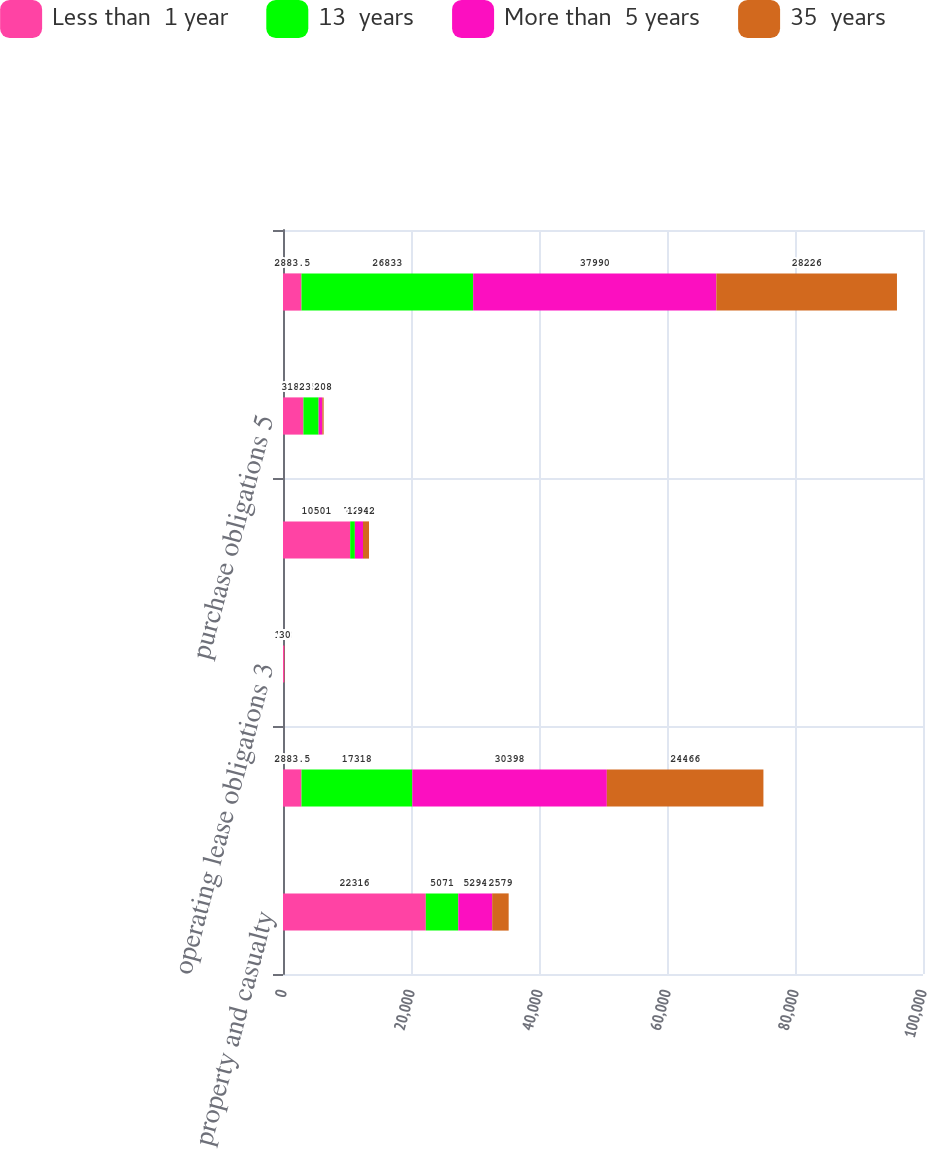Convert chart. <chart><loc_0><loc_0><loc_500><loc_500><stacked_bar_chart><ecel><fcel>property and casualty<fcel>life annuity and disability<fcel>operating lease obligations 3<fcel>long-term debt obligations 4<fcel>purchase obligations 5<fcel>Total<nl><fcel>Less than  1 year<fcel>22316<fcel>2883.5<fcel>163<fcel>10501<fcel>3188<fcel>2883.5<nl><fcel>13  years<fcel>5071<fcel>17318<fcel>42<fcel>726<fcel>2379<fcel>26833<nl><fcel>More than  5 years<fcel>5294<fcel>30398<fcel>63<fcel>1270<fcel>576<fcel>37990<nl><fcel>35  years<fcel>2579<fcel>24466<fcel>30<fcel>942<fcel>208<fcel>28226<nl></chart> 